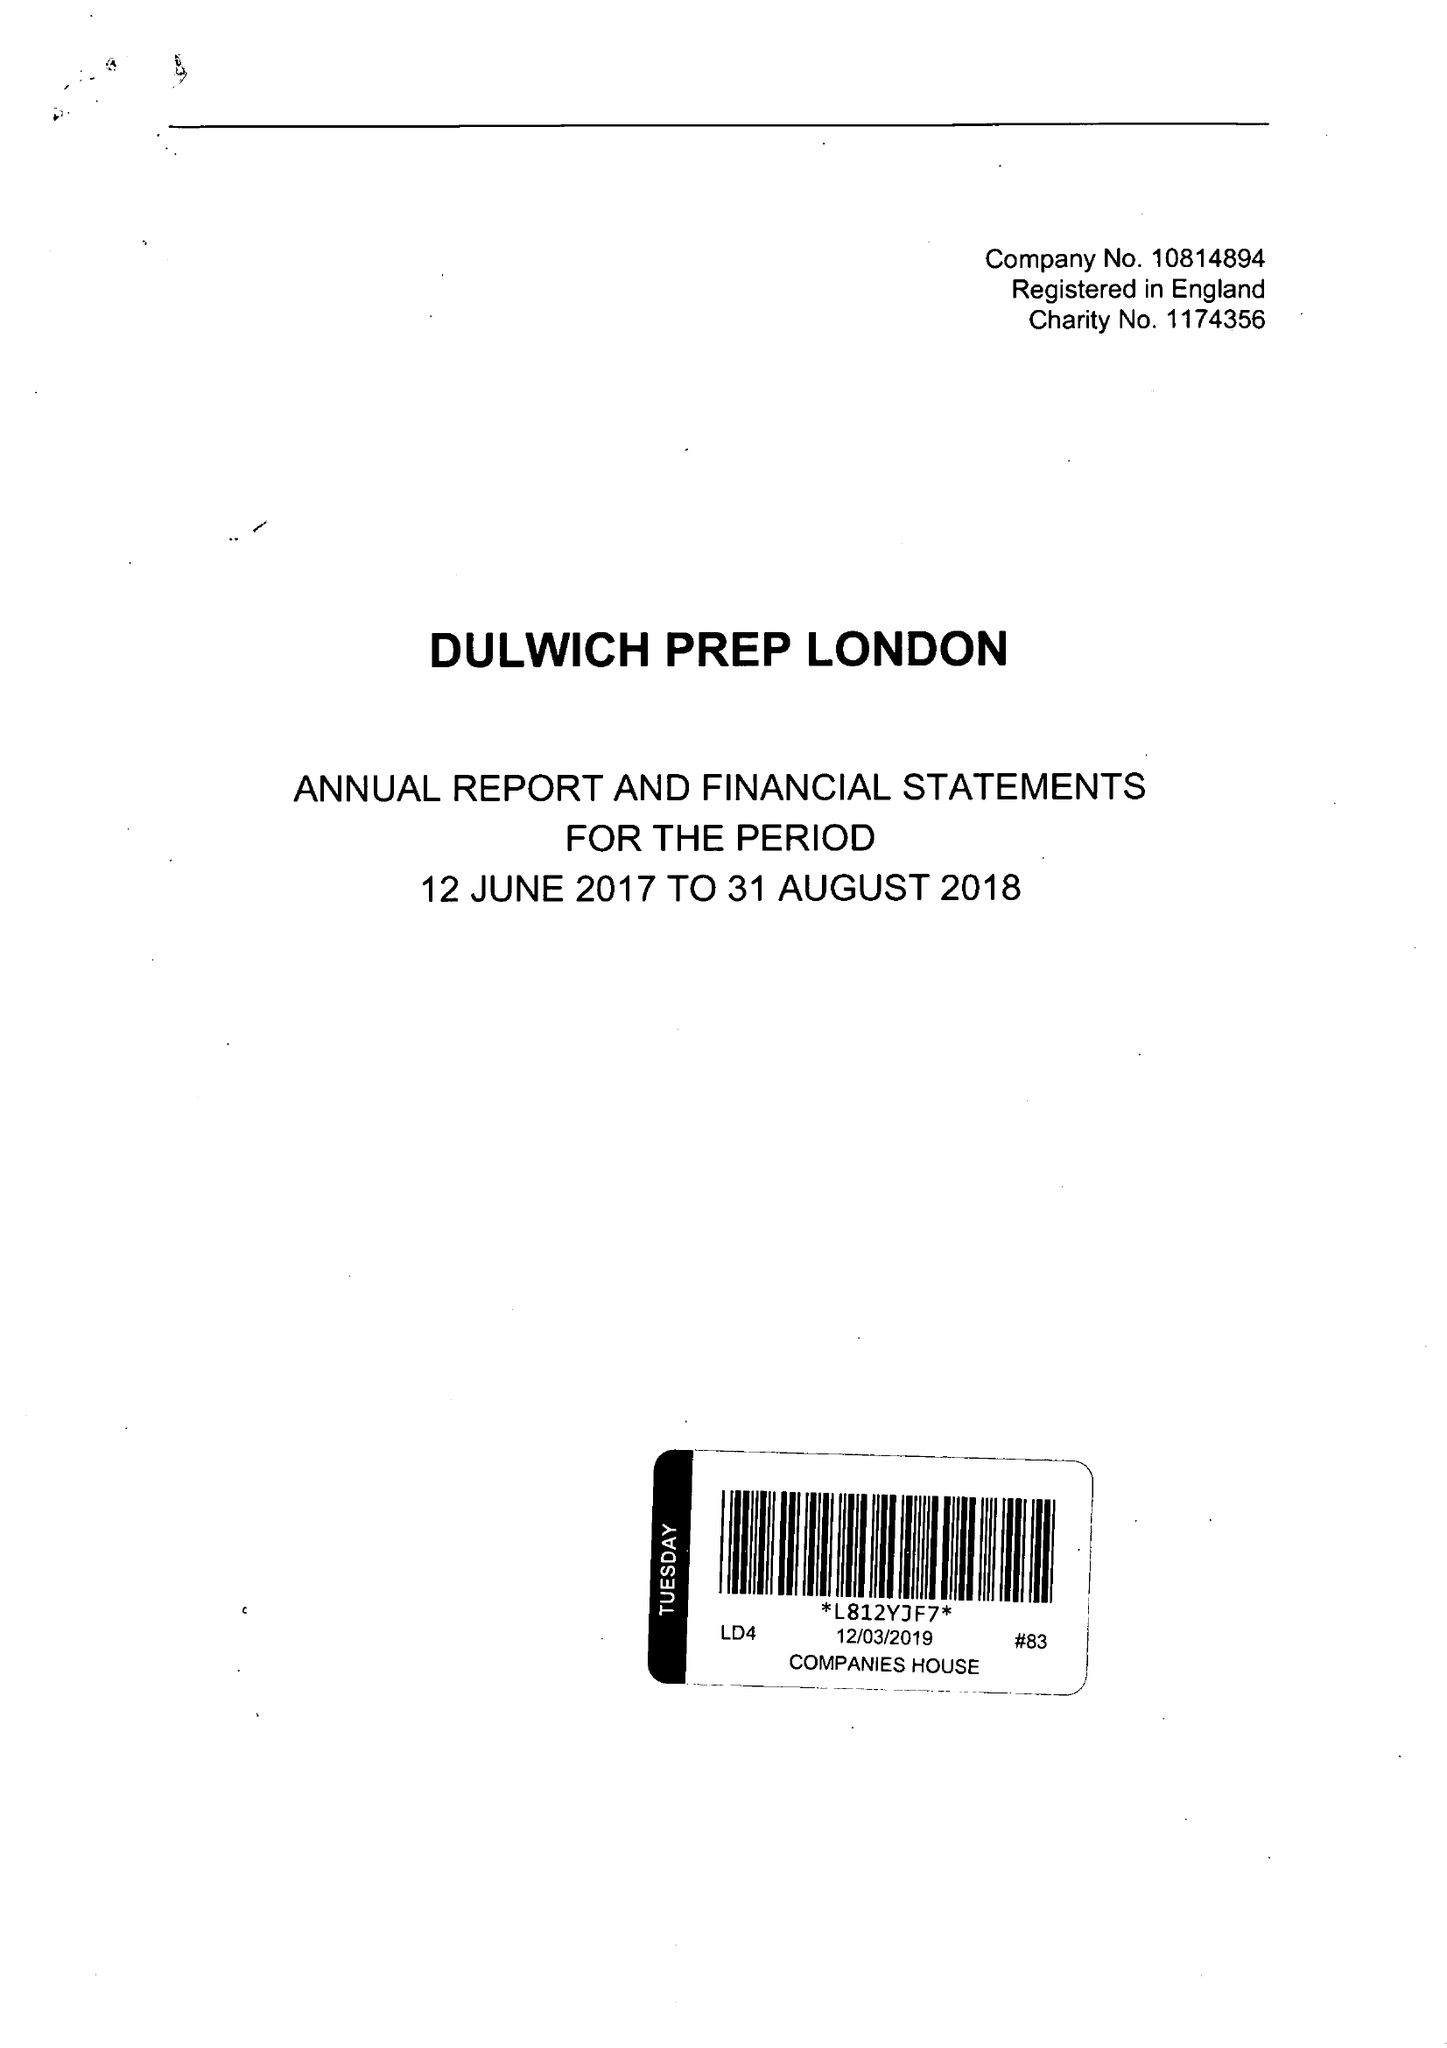What is the value for the report_date?
Answer the question using a single word or phrase. 2018-08-31 